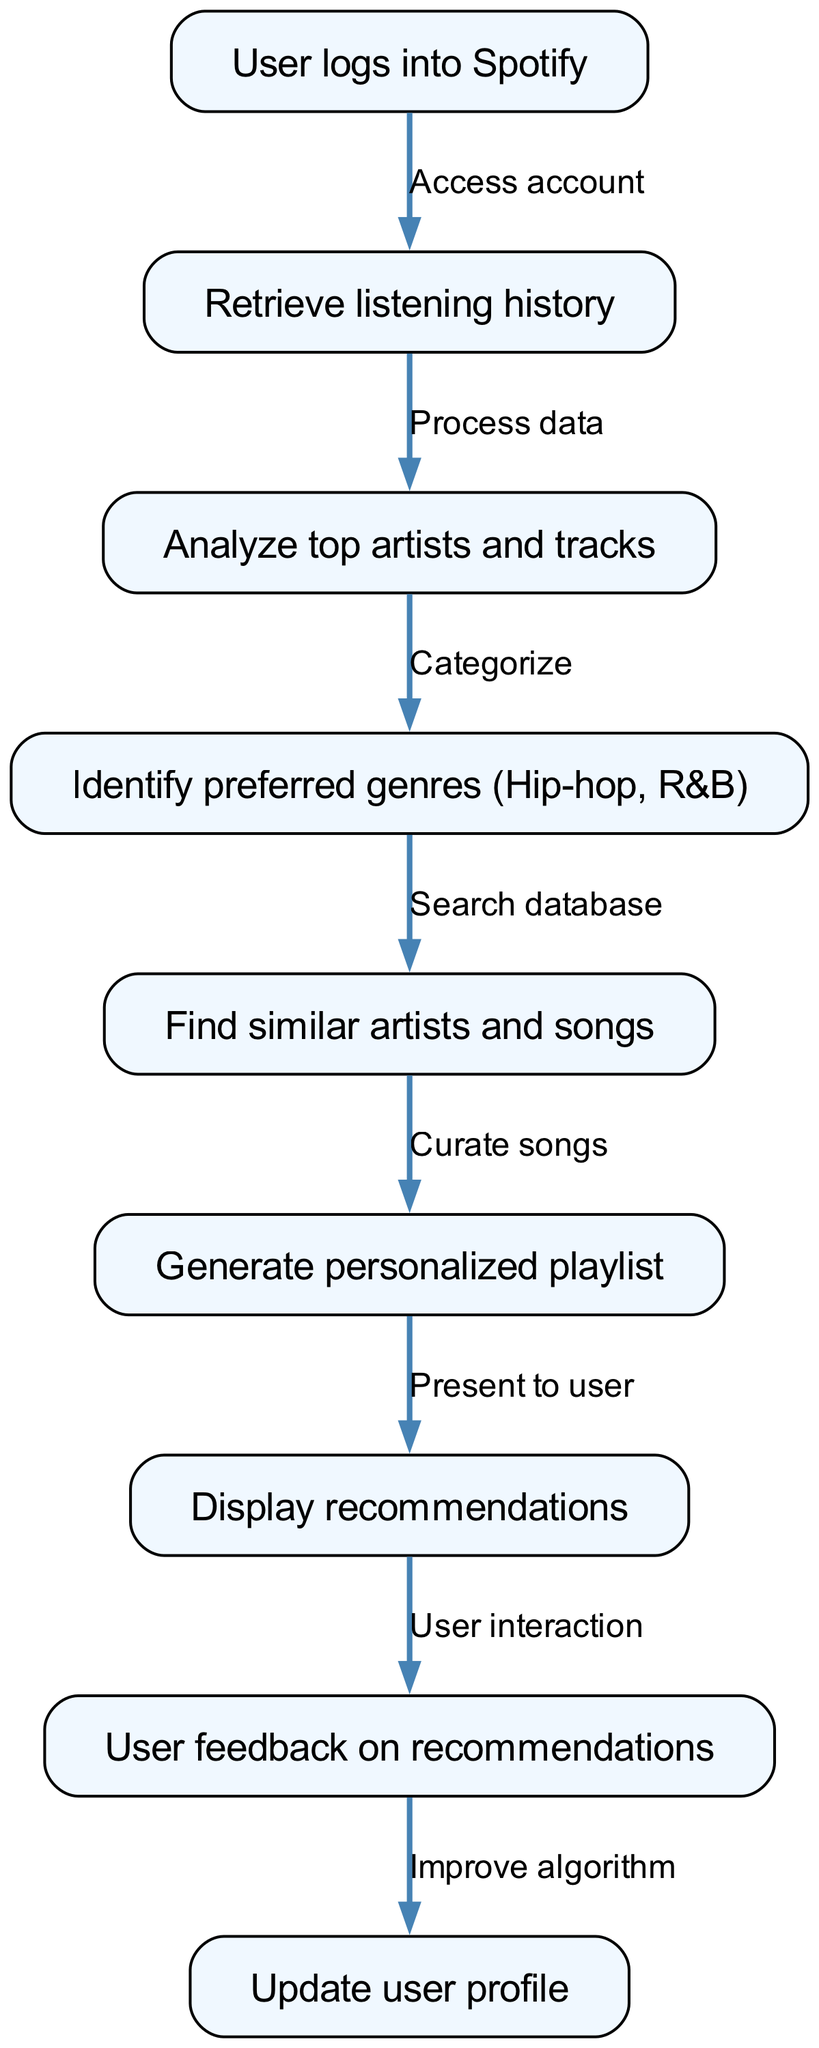What is the starting point of the flowchart? The flowchart begins with the "User logs into Spotify" node, which serves as the entry point for the user accessing the system.
Answer: User logs into Spotify How many nodes are there in the diagram? By counting all the nodes listed in the diagram, we find there are a total of 9 distinct nodes present, which represent various steps in the recommendation process.
Answer: 9 Which node comes after "Analyze top artists and tracks"? After "Analyze top artists and tracks," the flowchart directs to the "Identify preferred genres" node, indicating the process of categorizing the user's musical preferences.
Answer: Identify preferred genres What is the relationship between "Display recommendations" and "User feedback on recommendations"? The "Display recommendations" node leads to the "User feedback on recommendations" node, signifying that user interaction follows the display of generated recommendations.
Answer: User interaction What does the system do after receiving user feedback? Following the "User feedback on recommendations," the system proceeds to "Update user profile," which indicates that the feedback is utilized to improve user data and recommendation accuracy.
Answer: Improve algorithm What are the genres identified in the flowchart? The flowchart explicitly mentions "Hip-hop, R&B" as the preferred genres identified based on the user's listening history, thereby focusing the recommendation system.
Answer: Hip-hop, R&B How are similar artists and songs located? The process of finding similar artists and songs is executed through the "Search database" step, where the system accesses a database to pull relevant musical recommendations based on the user's interests.
Answer: Search database What happens at the end of the flowchart? At the end of the flowchart, the system's process concludes with "Update user profile," which reflects the incorporation of user feedback and data adjustments for future recommendations.
Answer: Update user profile What is the last node that the user interacts with? The last node that involves direct user interaction is "User feedback on recommendations," as this is where the user can provide insights regarding the recommendations received.
Answer: User feedback on recommendations 